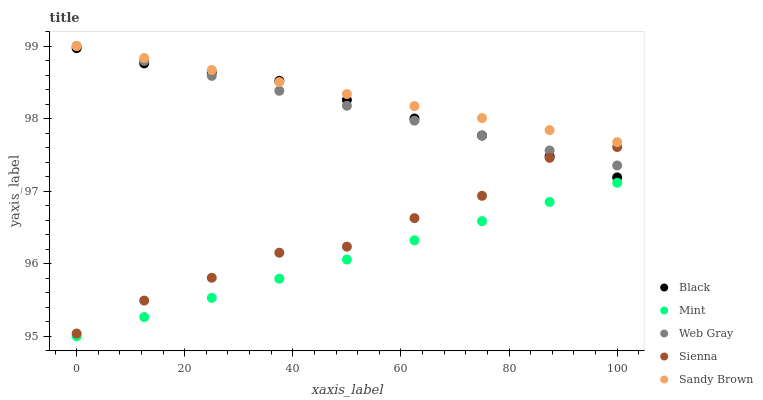Does Mint have the minimum area under the curve?
Answer yes or no. Yes. Does Sandy Brown have the maximum area under the curve?
Answer yes or no. Yes. Does Web Gray have the minimum area under the curve?
Answer yes or no. No. Does Web Gray have the maximum area under the curve?
Answer yes or no. No. Is Web Gray the smoothest?
Answer yes or no. Yes. Is Sienna the roughest?
Answer yes or no. Yes. Is Mint the smoothest?
Answer yes or no. No. Is Mint the roughest?
Answer yes or no. No. Does Mint have the lowest value?
Answer yes or no. Yes. Does Web Gray have the lowest value?
Answer yes or no. No. Does Sandy Brown have the highest value?
Answer yes or no. Yes. Does Mint have the highest value?
Answer yes or no. No. Is Sienna less than Sandy Brown?
Answer yes or no. Yes. Is Web Gray greater than Mint?
Answer yes or no. Yes. Does Black intersect Sandy Brown?
Answer yes or no. Yes. Is Black less than Sandy Brown?
Answer yes or no. No. Is Black greater than Sandy Brown?
Answer yes or no. No. Does Sienna intersect Sandy Brown?
Answer yes or no. No. 